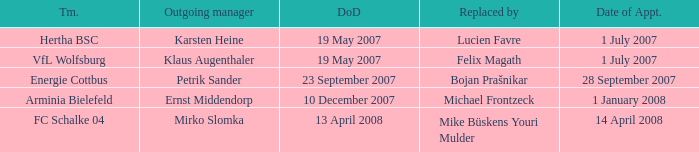When was the appointment date for the manager replaced by Lucien Favre? 1 July 2007. Would you be able to parse every entry in this table? {'header': ['Tm.', 'Outgoing manager', 'DoD', 'Replaced by', 'Date of Appt.'], 'rows': [['Hertha BSC', 'Karsten Heine', '19 May 2007', 'Lucien Favre', '1 July 2007'], ['VfL Wolfsburg', 'Klaus Augenthaler', '19 May 2007', 'Felix Magath', '1 July 2007'], ['Energie Cottbus', 'Petrik Sander', '23 September 2007', 'Bojan Prašnikar', '28 September 2007'], ['Arminia Bielefeld', 'Ernst Middendorp', '10 December 2007', 'Michael Frontzeck', '1 January 2008'], ['FC Schalke 04', 'Mirko Slomka', '13 April 2008', 'Mike Büskens Youri Mulder', '14 April 2008']]} 